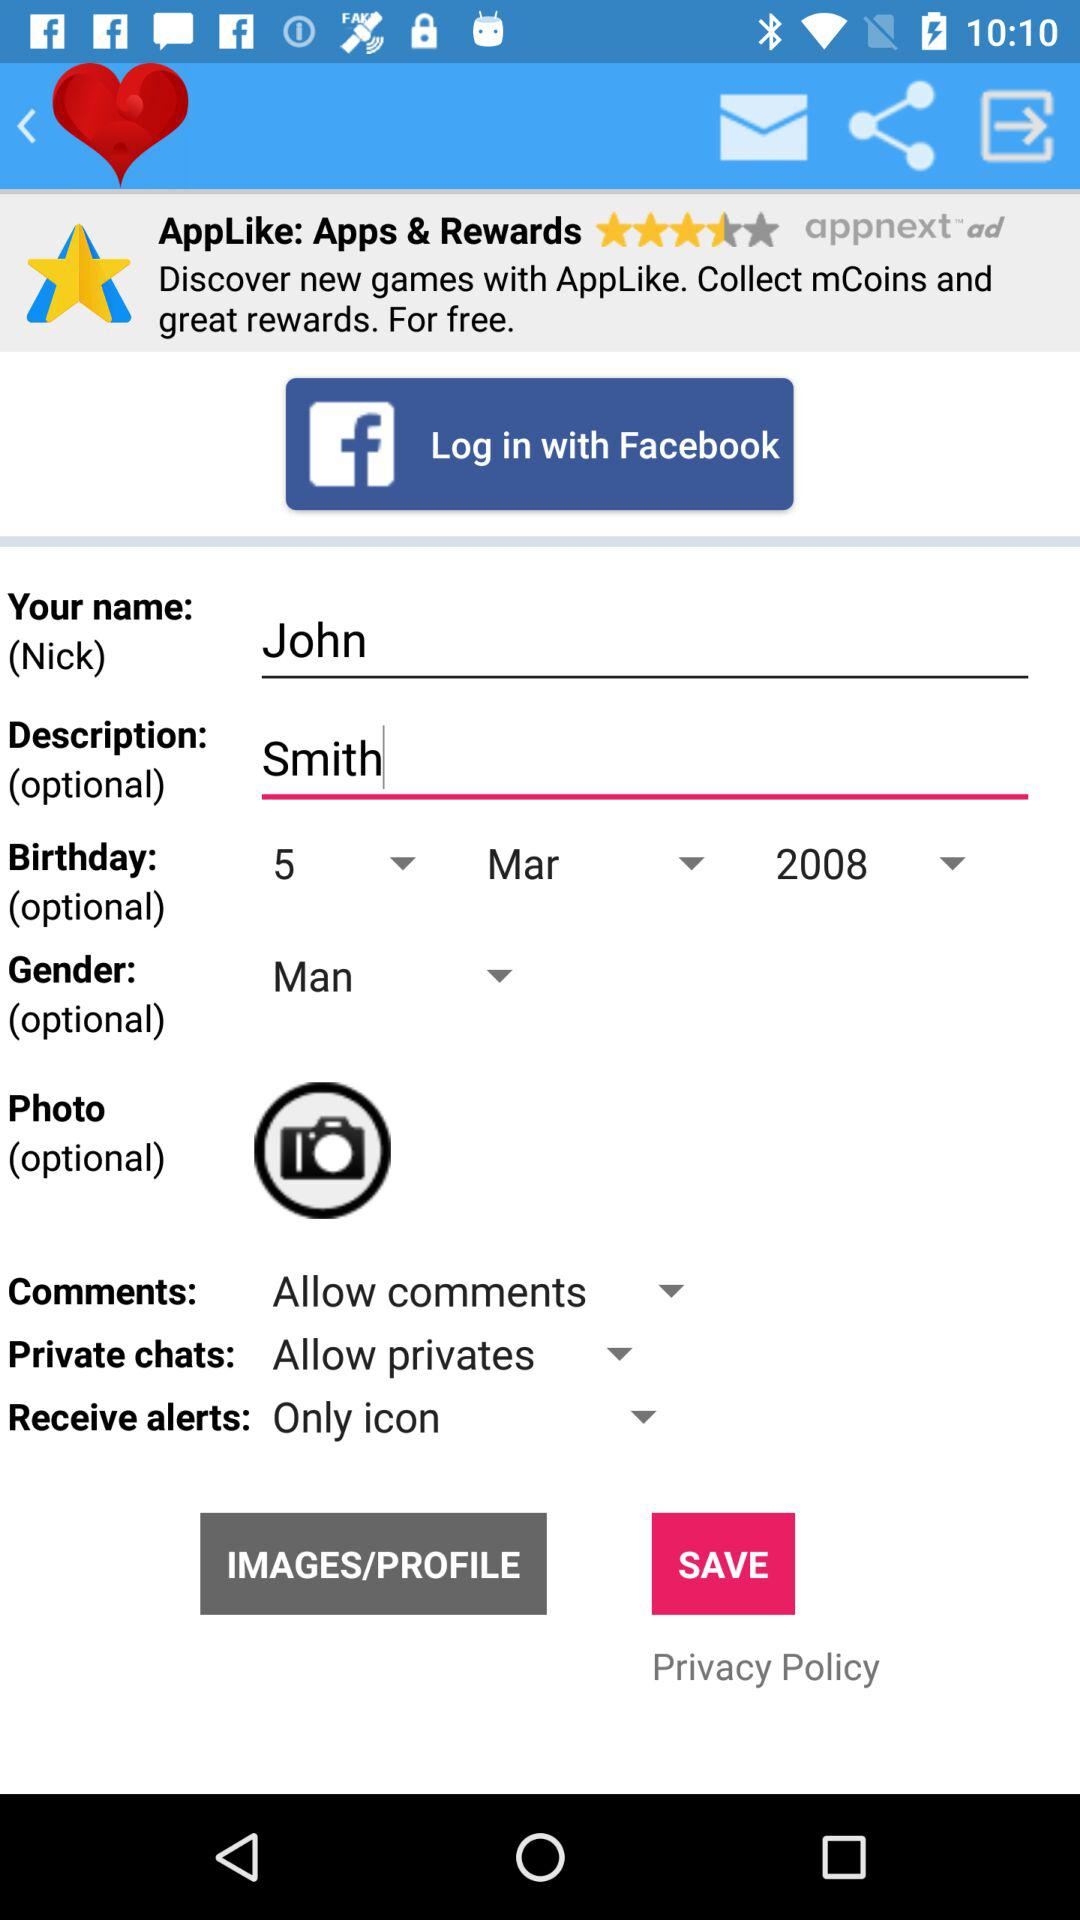Which option is selected in "Receive alerts"? The selected option in "Receive alerts" is "Only icon". 